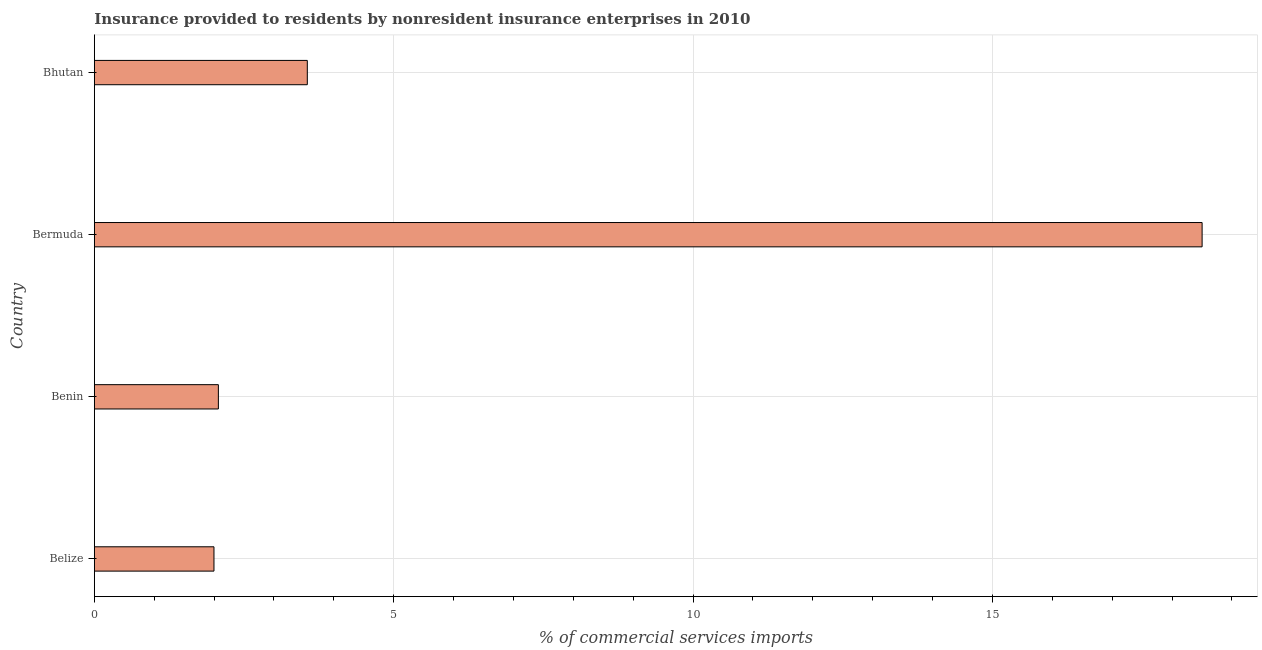Does the graph contain any zero values?
Provide a short and direct response. No. Does the graph contain grids?
Provide a succinct answer. Yes. What is the title of the graph?
Provide a succinct answer. Insurance provided to residents by nonresident insurance enterprises in 2010. What is the label or title of the X-axis?
Your answer should be compact. % of commercial services imports. What is the label or title of the Y-axis?
Your answer should be compact. Country. What is the insurance provided by non-residents in Benin?
Your response must be concise. 2.07. Across all countries, what is the maximum insurance provided by non-residents?
Your answer should be very brief. 18.5. Across all countries, what is the minimum insurance provided by non-residents?
Provide a short and direct response. 2. In which country was the insurance provided by non-residents maximum?
Provide a short and direct response. Bermuda. In which country was the insurance provided by non-residents minimum?
Provide a short and direct response. Belize. What is the sum of the insurance provided by non-residents?
Offer a very short reply. 26.13. What is the difference between the insurance provided by non-residents in Benin and Bermuda?
Your answer should be very brief. -16.43. What is the average insurance provided by non-residents per country?
Offer a terse response. 6.53. What is the median insurance provided by non-residents?
Ensure brevity in your answer.  2.81. In how many countries, is the insurance provided by non-residents greater than 16 %?
Give a very brief answer. 1. What is the ratio of the insurance provided by non-residents in Belize to that in Bhutan?
Make the answer very short. 0.56. Is the insurance provided by non-residents in Belize less than that in Benin?
Your answer should be compact. Yes. What is the difference between the highest and the second highest insurance provided by non-residents?
Offer a terse response. 14.95. What is the difference between the highest and the lowest insurance provided by non-residents?
Make the answer very short. 16.5. How many bars are there?
Offer a very short reply. 4. Are all the bars in the graph horizontal?
Give a very brief answer. Yes. Are the values on the major ticks of X-axis written in scientific E-notation?
Give a very brief answer. No. What is the % of commercial services imports in Belize?
Ensure brevity in your answer.  2. What is the % of commercial services imports in Benin?
Offer a terse response. 2.07. What is the % of commercial services imports in Bermuda?
Keep it short and to the point. 18.5. What is the % of commercial services imports of Bhutan?
Provide a short and direct response. 3.56. What is the difference between the % of commercial services imports in Belize and Benin?
Your response must be concise. -0.07. What is the difference between the % of commercial services imports in Belize and Bermuda?
Make the answer very short. -16.5. What is the difference between the % of commercial services imports in Belize and Bhutan?
Give a very brief answer. -1.56. What is the difference between the % of commercial services imports in Benin and Bermuda?
Your answer should be very brief. -16.43. What is the difference between the % of commercial services imports in Benin and Bhutan?
Keep it short and to the point. -1.49. What is the difference between the % of commercial services imports in Bermuda and Bhutan?
Keep it short and to the point. 14.95. What is the ratio of the % of commercial services imports in Belize to that in Bermuda?
Keep it short and to the point. 0.11. What is the ratio of the % of commercial services imports in Belize to that in Bhutan?
Make the answer very short. 0.56. What is the ratio of the % of commercial services imports in Benin to that in Bermuda?
Offer a very short reply. 0.11. What is the ratio of the % of commercial services imports in Benin to that in Bhutan?
Your response must be concise. 0.58. What is the ratio of the % of commercial services imports in Bermuda to that in Bhutan?
Offer a terse response. 5.2. 